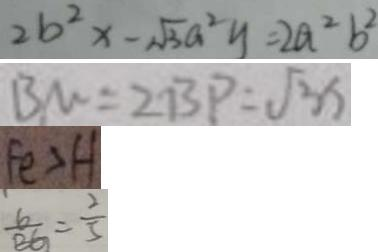Convert formula to latex. <formula><loc_0><loc_0><loc_500><loc_500>2 b ^ { 2 } x - \sqrt { 3 } a ^ { 2 } y = 2 a ^ { 2 } b ^ { 2 } 
 B M = 2 B P = \sqrt { 3 } x 
 F e > H 
 \frac { G } { B G } = \frac { 2 } { 5 }</formula> 